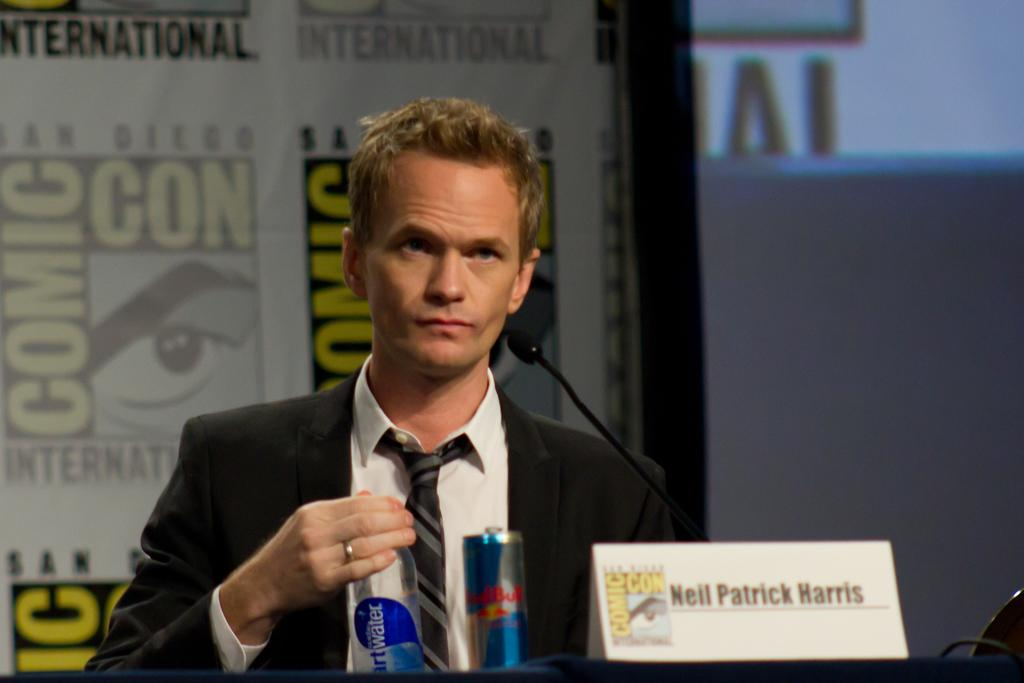What is the person in the image wearing? There is a person wearing a suit in the image. What type of objects can be seen in the image besides the person? There is a bottle, a can, a microphone, a screen, and a banner in the image. What might the person be using the microphone for? The microphone suggests that the person might be giving a speech or presentation. What is the purpose of the screen in the image? The screen might be used for displaying information or visuals during the presentation. How does the farmer feel about the limit of their land in the image? There is no farmer or mention of land in the image; it features a person in a suit, a bottle, a can, a microphone, a screen, and a banner. 